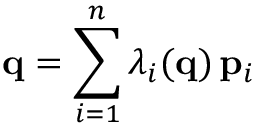Convert formula to latex. <formula><loc_0><loc_0><loc_500><loc_500>{ q } = \sum _ { i = 1 } ^ { n } \lambda _ { i } ( { q } ) \, { p } _ { i }</formula> 